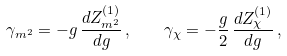Convert formula to latex. <formula><loc_0><loc_0><loc_500><loc_500>\gamma _ { m ^ { 2 } } = - g \, \frac { d Z _ { m ^ { 2 } } ^ { ( 1 ) } } { d g } \, , \quad \gamma _ { \chi } = - \frac { g } { 2 } \, \frac { d Z _ { \chi } ^ { ( 1 ) } } { d g } \, ,</formula> 